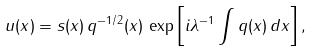Convert formula to latex. <formula><loc_0><loc_0><loc_500><loc_500>u ( x ) = s ( x ) \, q ^ { - 1 / 2 } ( x ) \, \exp \left [ i \lambda ^ { - 1 } \int q ( x ) \, d x \right ] ,</formula> 